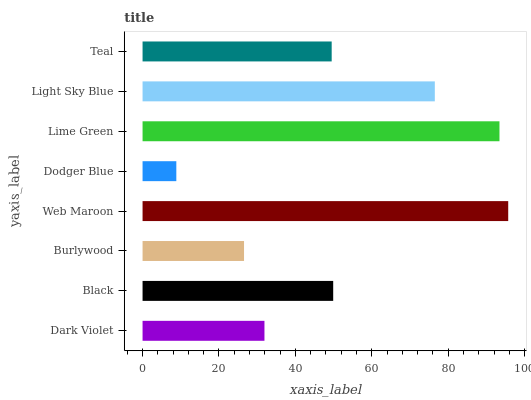Is Dodger Blue the minimum?
Answer yes or no. Yes. Is Web Maroon the maximum?
Answer yes or no. Yes. Is Black the minimum?
Answer yes or no. No. Is Black the maximum?
Answer yes or no. No. Is Black greater than Dark Violet?
Answer yes or no. Yes. Is Dark Violet less than Black?
Answer yes or no. Yes. Is Dark Violet greater than Black?
Answer yes or no. No. Is Black less than Dark Violet?
Answer yes or no. No. Is Black the high median?
Answer yes or no. Yes. Is Teal the low median?
Answer yes or no. Yes. Is Burlywood the high median?
Answer yes or no. No. Is Dodger Blue the low median?
Answer yes or no. No. 